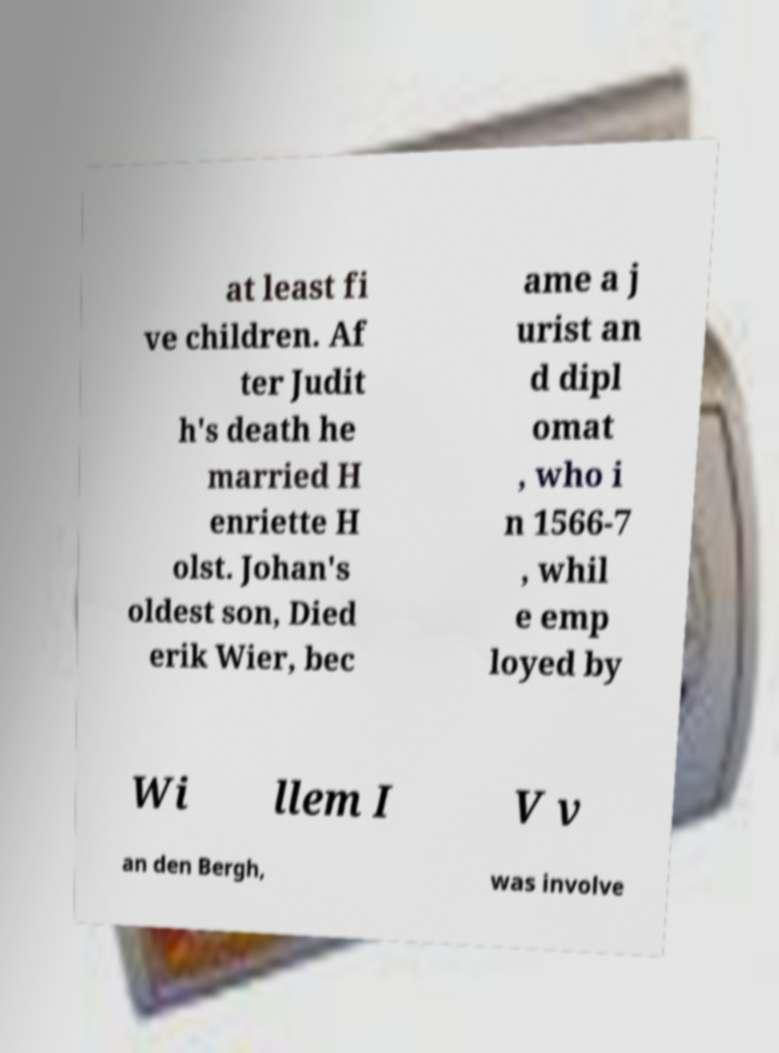Please read and relay the text visible in this image. What does it say? at least fi ve children. Af ter Judit h's death he married H enriette H olst. Johan's oldest son, Died erik Wier, bec ame a j urist an d dipl omat , who i n 1566-7 , whil e emp loyed by Wi llem I V v an den Bergh, was involve 